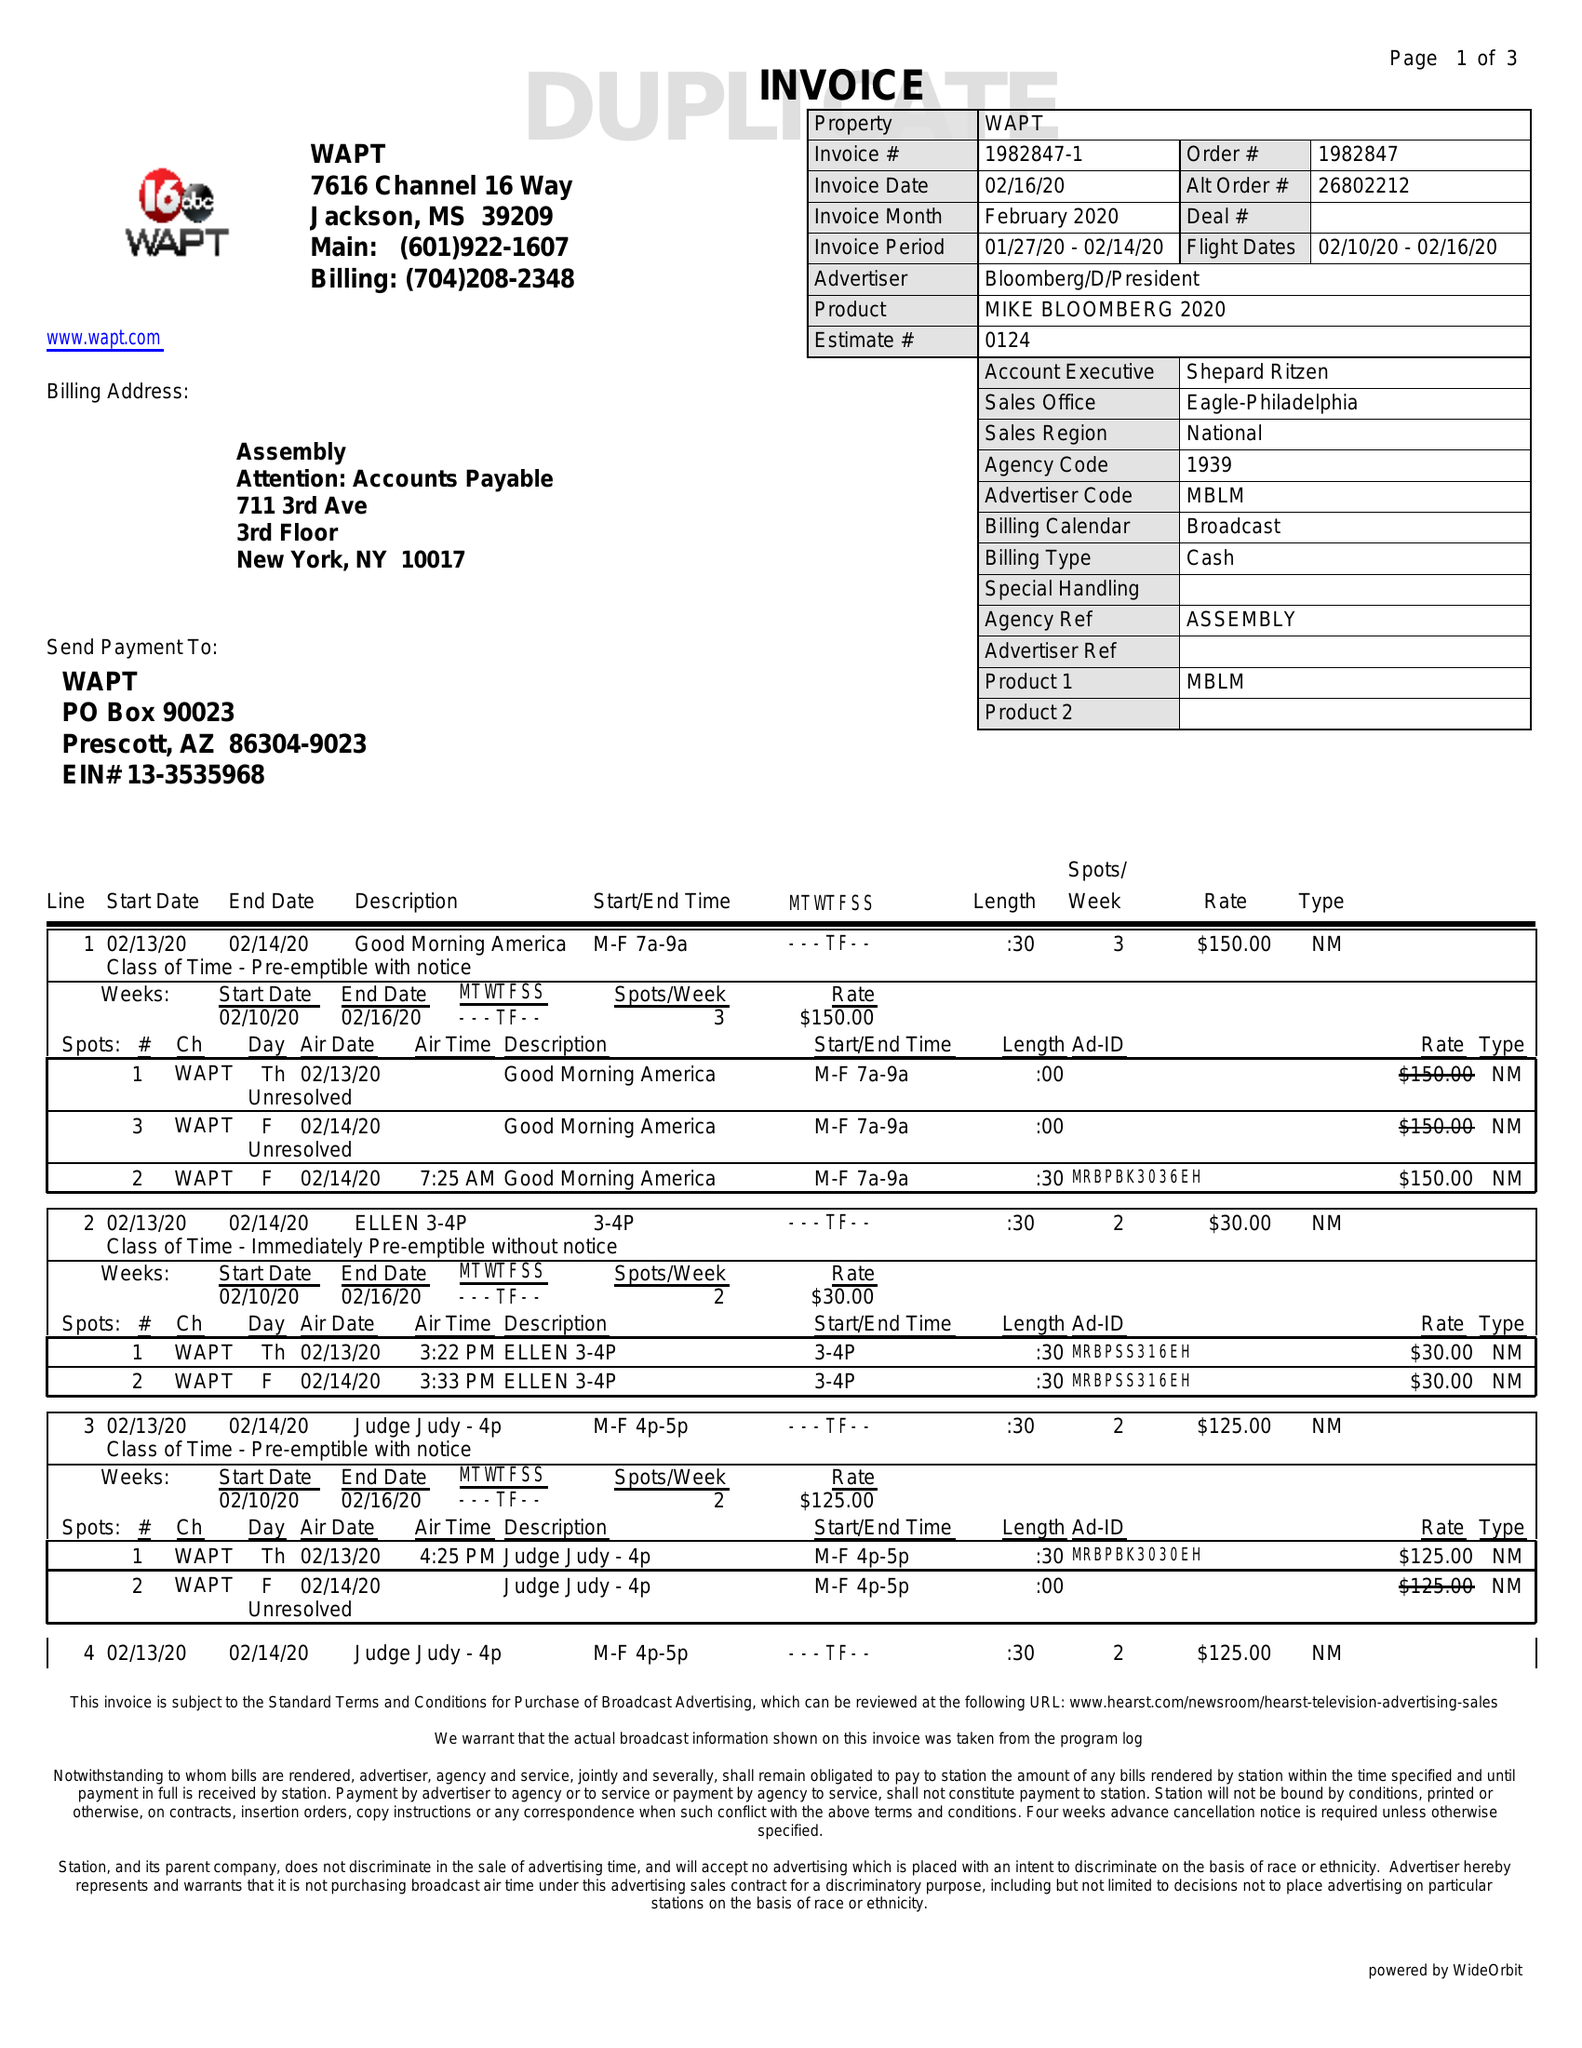What is the value for the contract_num?
Answer the question using a single word or phrase. 1982847 